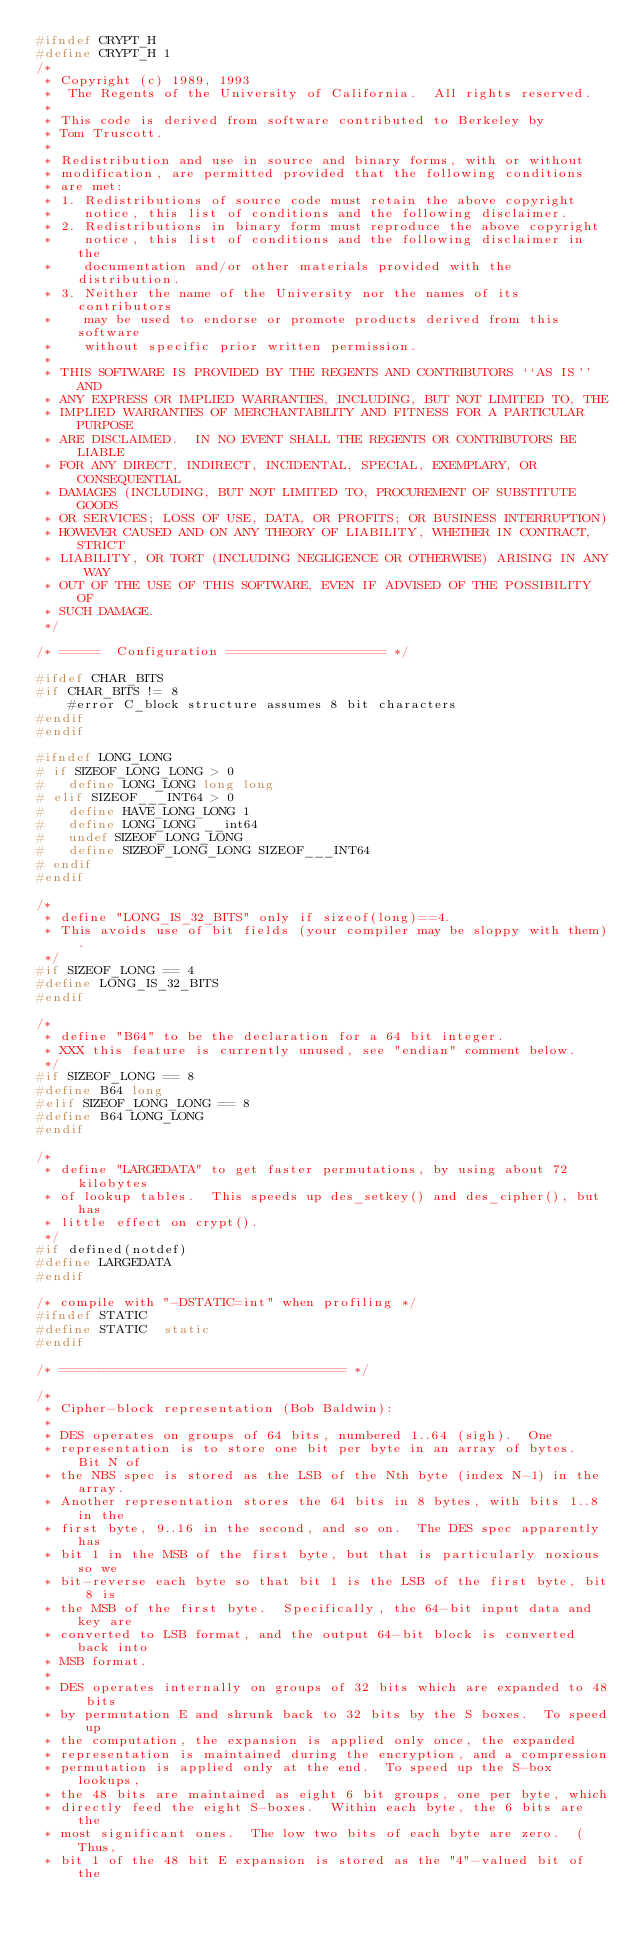Convert code to text. <code><loc_0><loc_0><loc_500><loc_500><_C_>#ifndef CRYPT_H
#define CRYPT_H 1
/*
 * Copyright (c) 1989, 1993
 *	The Regents of the University of California.  All rights reserved.
 *
 * This code is derived from software contributed to Berkeley by
 * Tom Truscott.
 *
 * Redistribution and use in source and binary forms, with or without
 * modification, are permitted provided that the following conditions
 * are met:
 * 1. Redistributions of source code must retain the above copyright
 *    notice, this list of conditions and the following disclaimer.
 * 2. Redistributions in binary form must reproduce the above copyright
 *    notice, this list of conditions and the following disclaimer in the
 *    documentation and/or other materials provided with the distribution.
 * 3. Neither the name of the University nor the names of its contributors
 *    may be used to endorse or promote products derived from this software
 *    without specific prior written permission.
 *
 * THIS SOFTWARE IS PROVIDED BY THE REGENTS AND CONTRIBUTORS ``AS IS'' AND
 * ANY EXPRESS OR IMPLIED WARRANTIES, INCLUDING, BUT NOT LIMITED TO, THE
 * IMPLIED WARRANTIES OF MERCHANTABILITY AND FITNESS FOR A PARTICULAR PURPOSE
 * ARE DISCLAIMED.  IN NO EVENT SHALL THE REGENTS OR CONTRIBUTORS BE LIABLE
 * FOR ANY DIRECT, INDIRECT, INCIDENTAL, SPECIAL, EXEMPLARY, OR CONSEQUENTIAL
 * DAMAGES (INCLUDING, BUT NOT LIMITED TO, PROCUREMENT OF SUBSTITUTE GOODS
 * OR SERVICES; LOSS OF USE, DATA, OR PROFITS; OR BUSINESS INTERRUPTION)
 * HOWEVER CAUSED AND ON ANY THEORY OF LIABILITY, WHETHER IN CONTRACT, STRICT
 * LIABILITY, OR TORT (INCLUDING NEGLIGENCE OR OTHERWISE) ARISING IN ANY WAY
 * OUT OF THE USE OF THIS SOFTWARE, EVEN IF ADVISED OF THE POSSIBILITY OF
 * SUCH DAMAGE.
 */

/* =====  Configuration ==================== */

#ifdef CHAR_BITS
#if CHAR_BITS != 8
	#error C_block structure assumes 8 bit characters
#endif
#endif

#ifndef LONG_LONG
# if SIZEOF_LONG_LONG > 0
#   define LONG_LONG long long
# elif SIZEOF___INT64 > 0
#   define HAVE_LONG_LONG 1
#   define LONG_LONG __int64
#   undef SIZEOF_LONG_LONG
#   define SIZEOF_LONG_LONG SIZEOF___INT64
# endif
#endif

/*
 * define "LONG_IS_32_BITS" only if sizeof(long)==4.
 * This avoids use of bit fields (your compiler may be sloppy with them).
 */
#if SIZEOF_LONG == 4
#define	LONG_IS_32_BITS
#endif

/*
 * define "B64" to be the declaration for a 64 bit integer.
 * XXX this feature is currently unused, see "endian" comment below.
 */
#if SIZEOF_LONG == 8
#define	B64	long
#elif SIZEOF_LONG_LONG == 8
#define	B64	LONG_LONG
#endif

/*
 * define "LARGEDATA" to get faster permutations, by using about 72 kilobytes
 * of lookup tables.  This speeds up des_setkey() and des_cipher(), but has
 * little effect on crypt().
 */
#if defined(notdef)
#define	LARGEDATA
#endif

/* compile with "-DSTATIC=int" when profiling */
#ifndef STATIC
#define	STATIC	static
#endif

/* ==================================== */

/*
 * Cipher-block representation (Bob Baldwin):
 *
 * DES operates on groups of 64 bits, numbered 1..64 (sigh).  One
 * representation is to store one bit per byte in an array of bytes.  Bit N of
 * the NBS spec is stored as the LSB of the Nth byte (index N-1) in the array.
 * Another representation stores the 64 bits in 8 bytes, with bits 1..8 in the
 * first byte, 9..16 in the second, and so on.  The DES spec apparently has
 * bit 1 in the MSB of the first byte, but that is particularly noxious so we
 * bit-reverse each byte so that bit 1 is the LSB of the first byte, bit 8 is
 * the MSB of the first byte.  Specifically, the 64-bit input data and key are
 * converted to LSB format, and the output 64-bit block is converted back into
 * MSB format.
 *
 * DES operates internally on groups of 32 bits which are expanded to 48 bits
 * by permutation E and shrunk back to 32 bits by the S boxes.  To speed up
 * the computation, the expansion is applied only once, the expanded
 * representation is maintained during the encryption, and a compression
 * permutation is applied only at the end.  To speed up the S-box lookups,
 * the 48 bits are maintained as eight 6 bit groups, one per byte, which
 * directly feed the eight S-boxes.  Within each byte, the 6 bits are the
 * most significant ones.  The low two bits of each byte are zero.  (Thus,
 * bit 1 of the 48 bit E expansion is stored as the "4"-valued bit of the</code> 